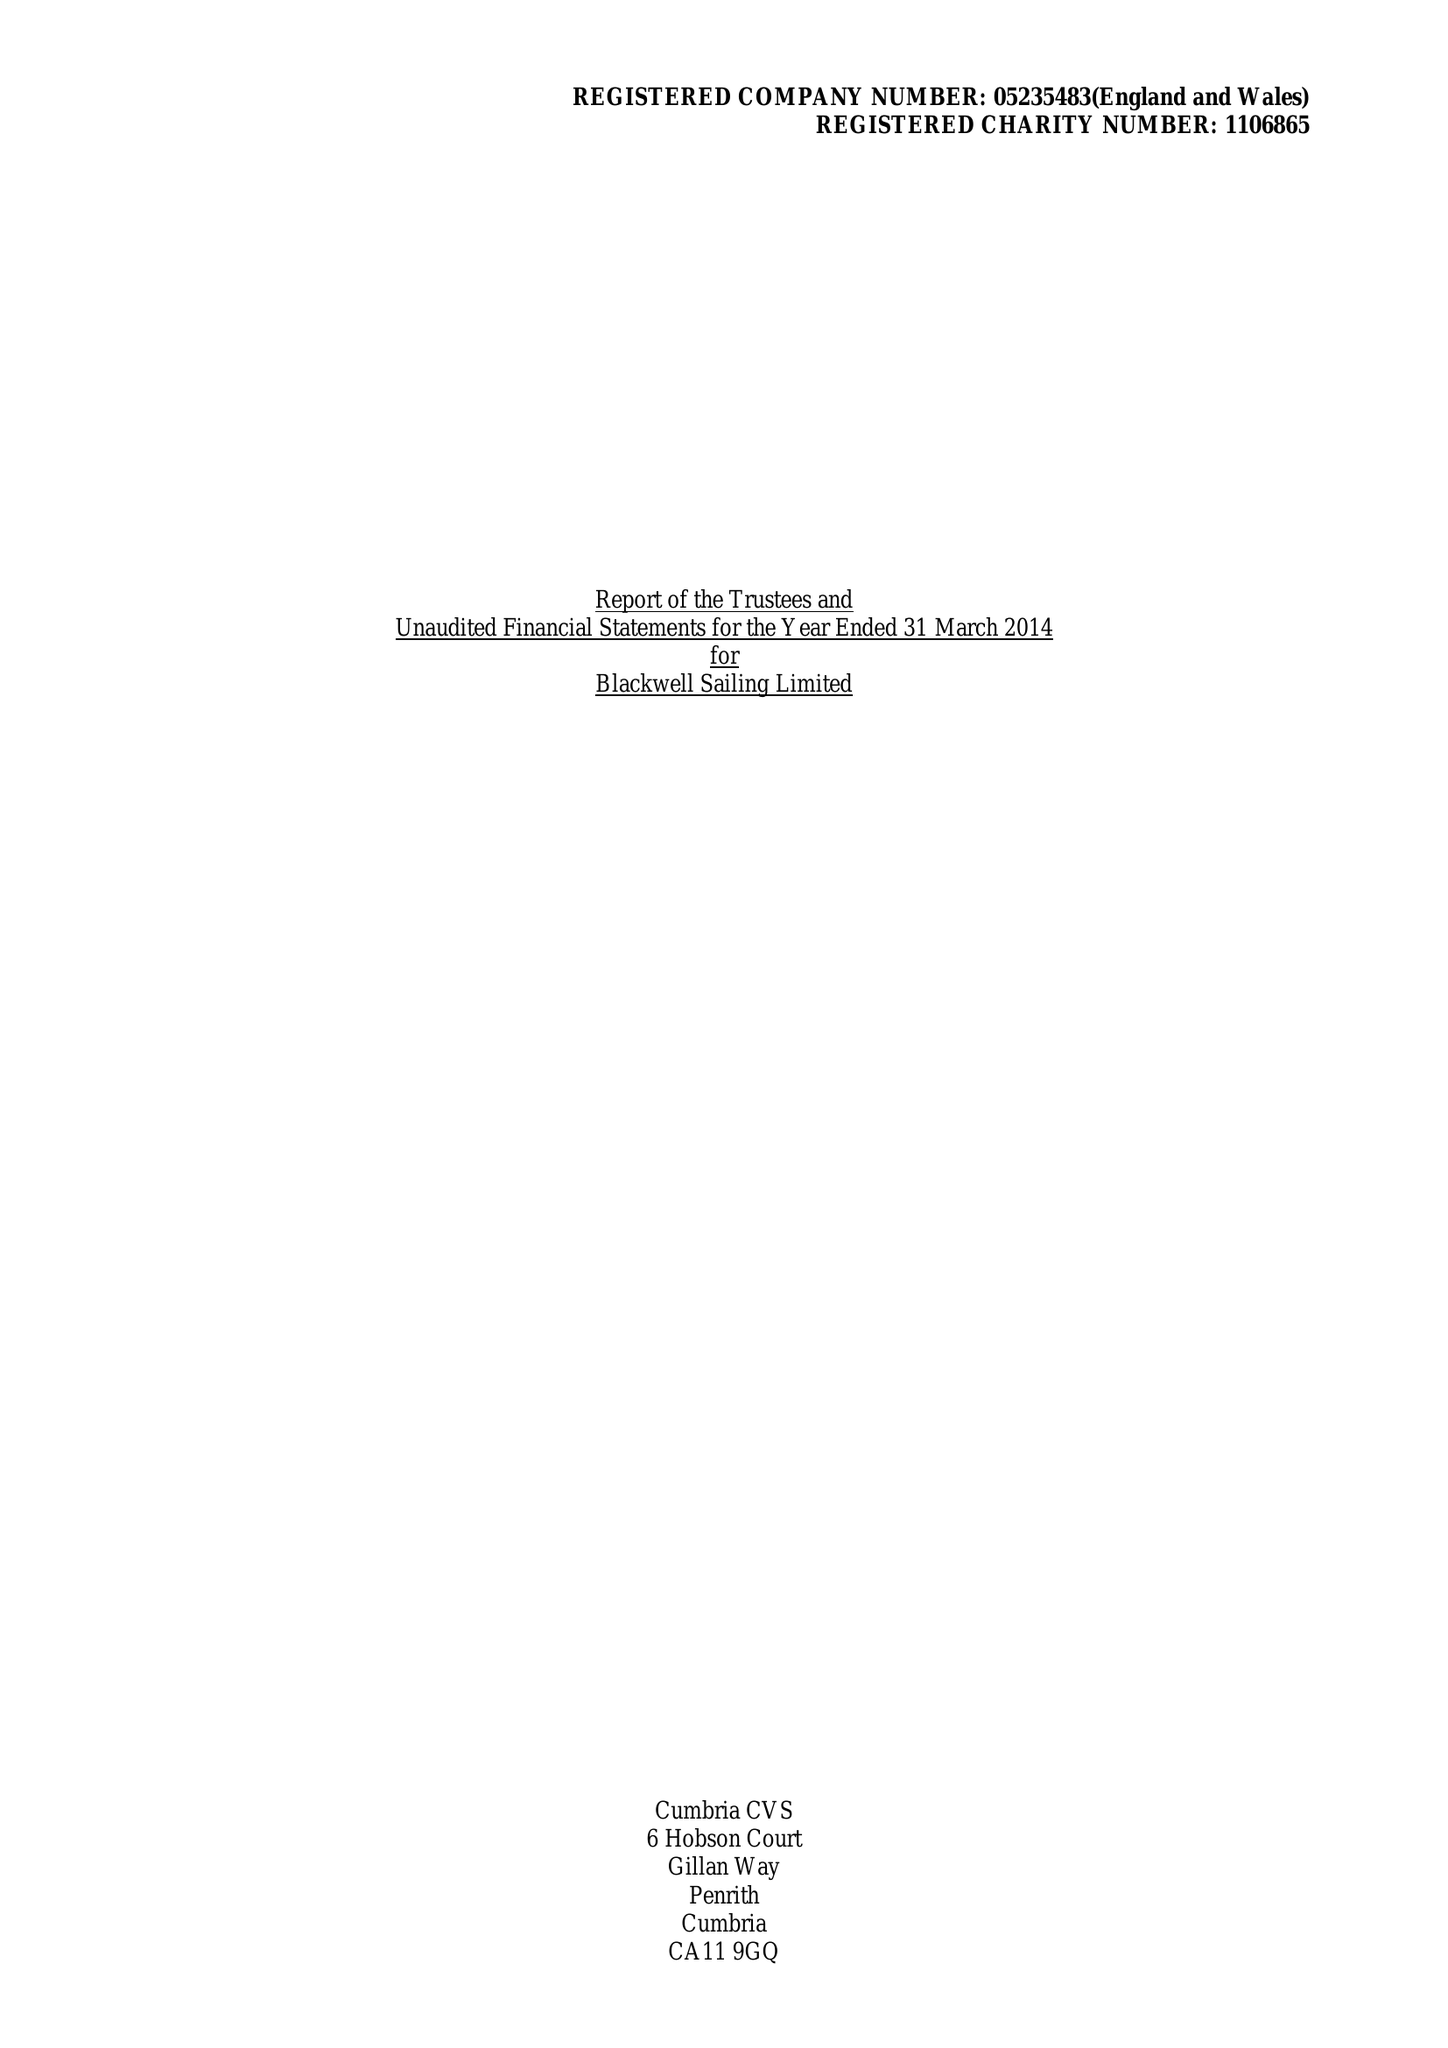What is the value for the address__post_town?
Answer the question using a single word or phrase. WINDERMERE 